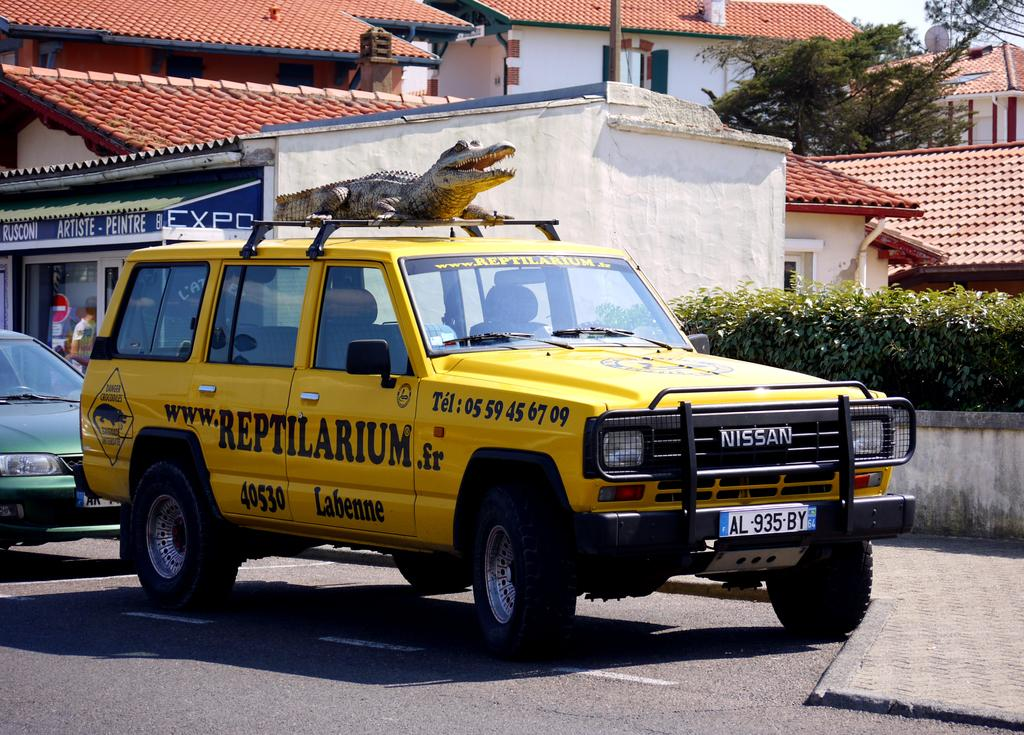Provide a one-sentence caption for the provided image. A yellow SUV with "Reptilarium" written on the side doors. 